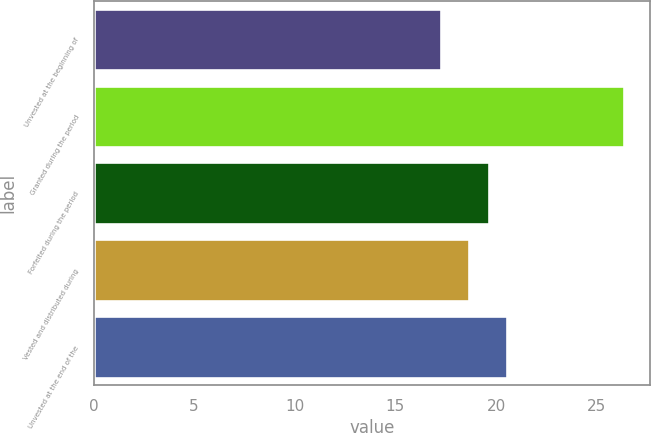Convert chart. <chart><loc_0><loc_0><loc_500><loc_500><bar_chart><fcel>Unvested at the beginning of<fcel>Granted during the period<fcel>Forfeited during the period<fcel>Vested and distributed during<fcel>Unvested at the end of the<nl><fcel>17.25<fcel>26.34<fcel>19.65<fcel>18.68<fcel>20.56<nl></chart> 